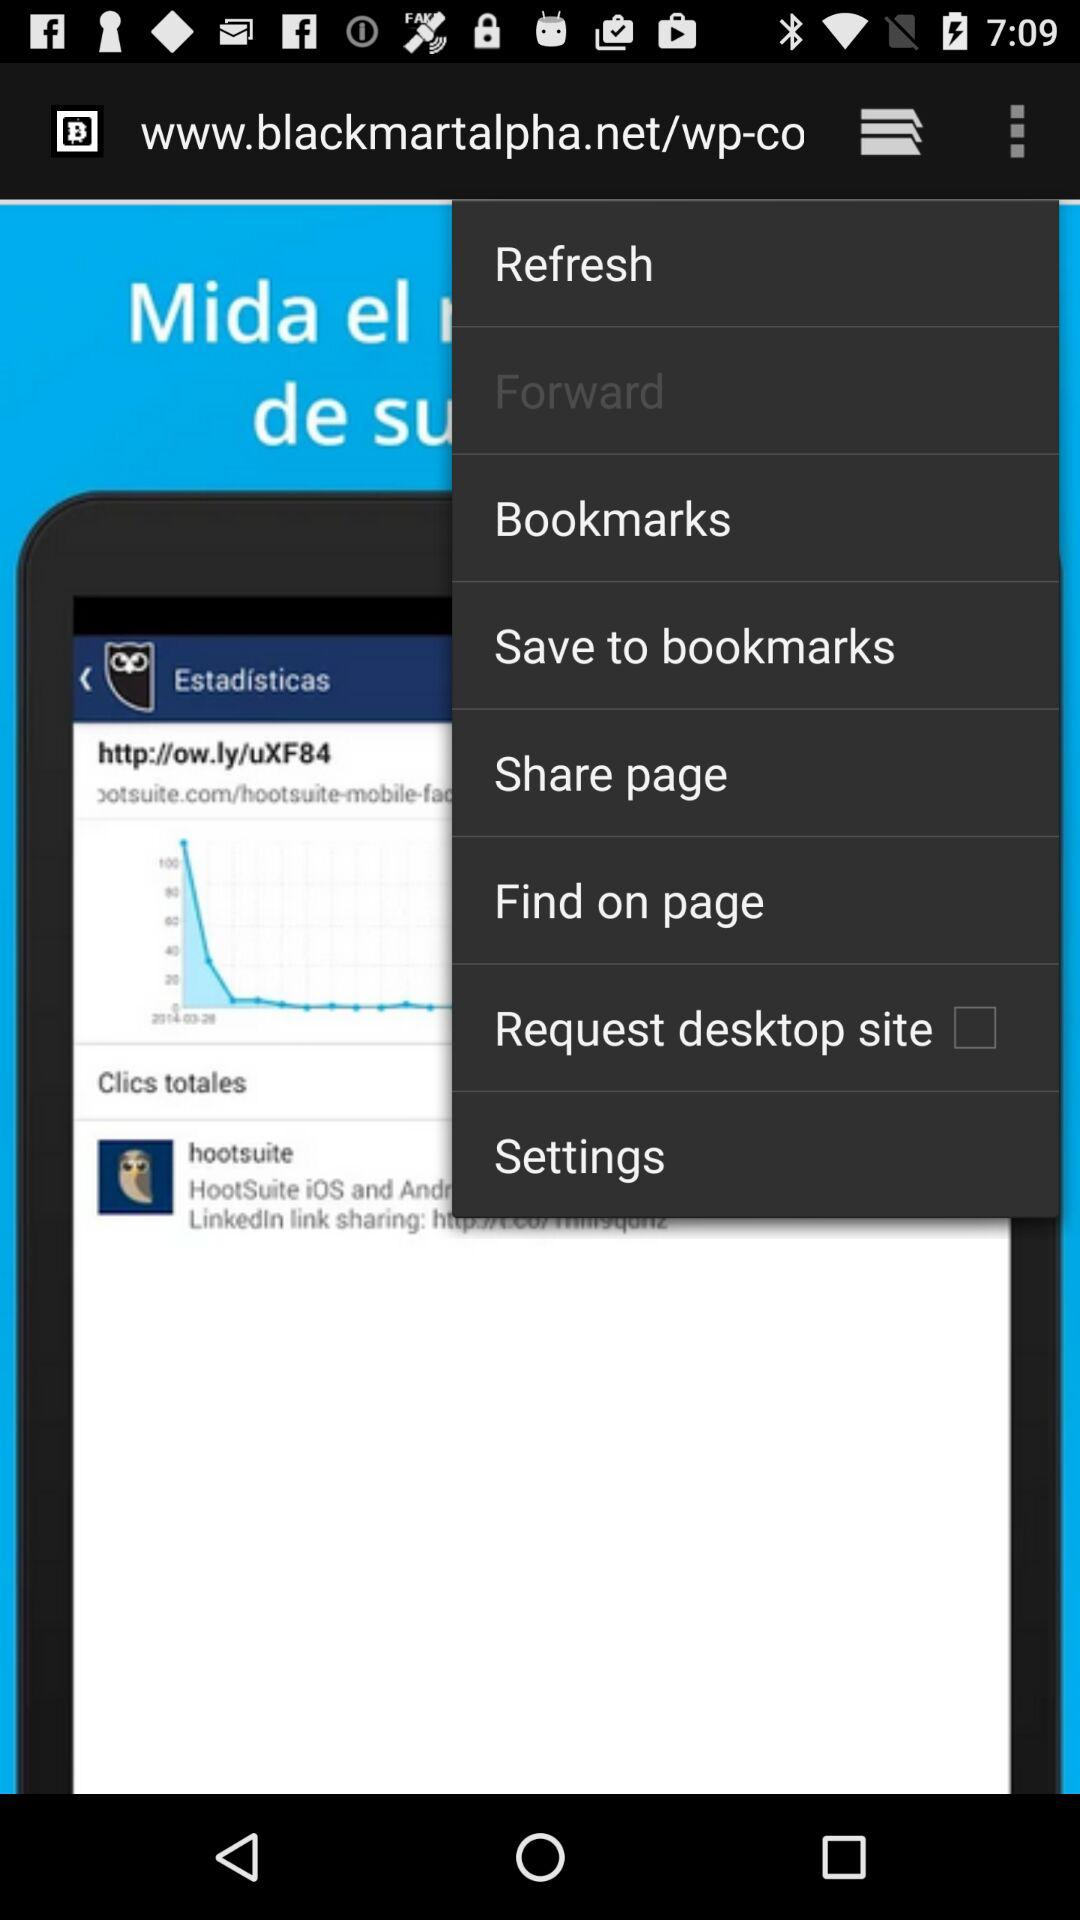What is the status of the "Request desktop site"? The status is "off". 